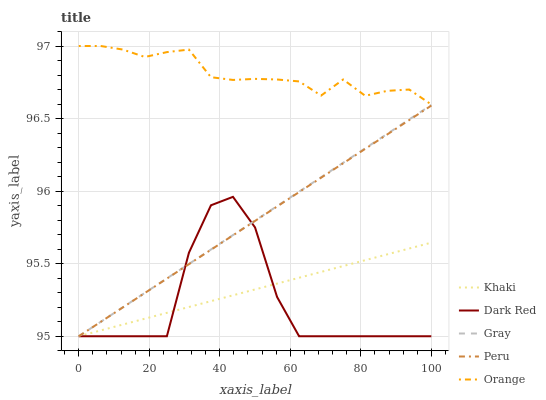Does Dark Red have the minimum area under the curve?
Answer yes or no. Yes. Does Orange have the maximum area under the curve?
Answer yes or no. Yes. Does Khaki have the minimum area under the curve?
Answer yes or no. No. Does Khaki have the maximum area under the curve?
Answer yes or no. No. Is Peru the smoothest?
Answer yes or no. Yes. Is Dark Red the roughest?
Answer yes or no. Yes. Is Khaki the smoothest?
Answer yes or no. No. Is Khaki the roughest?
Answer yes or no. No. Does Dark Red have the highest value?
Answer yes or no. No. Is Dark Red less than Orange?
Answer yes or no. Yes. Is Orange greater than Dark Red?
Answer yes or no. Yes. Does Dark Red intersect Orange?
Answer yes or no. No. 